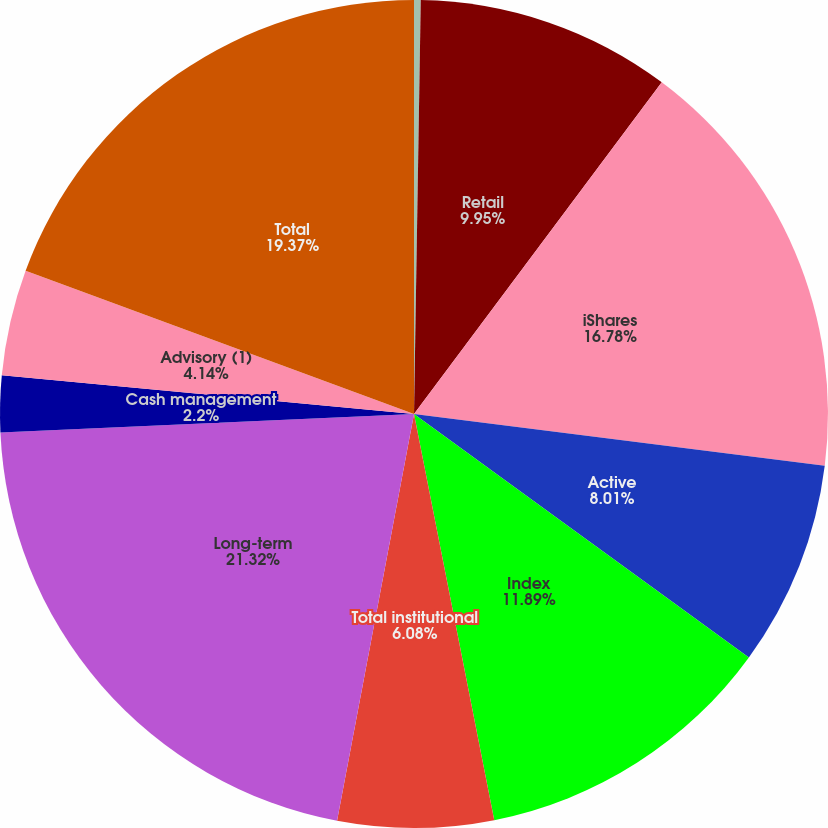Convert chart. <chart><loc_0><loc_0><loc_500><loc_500><pie_chart><fcel>(in millions)<fcel>Retail<fcel>iShares<fcel>Active<fcel>Index<fcel>Total institutional<fcel>Long-term<fcel>Cash management<fcel>Advisory (1)<fcel>Total<nl><fcel>0.26%<fcel>9.95%<fcel>16.78%<fcel>8.01%<fcel>11.89%<fcel>6.08%<fcel>21.31%<fcel>2.2%<fcel>4.14%<fcel>19.37%<nl></chart> 